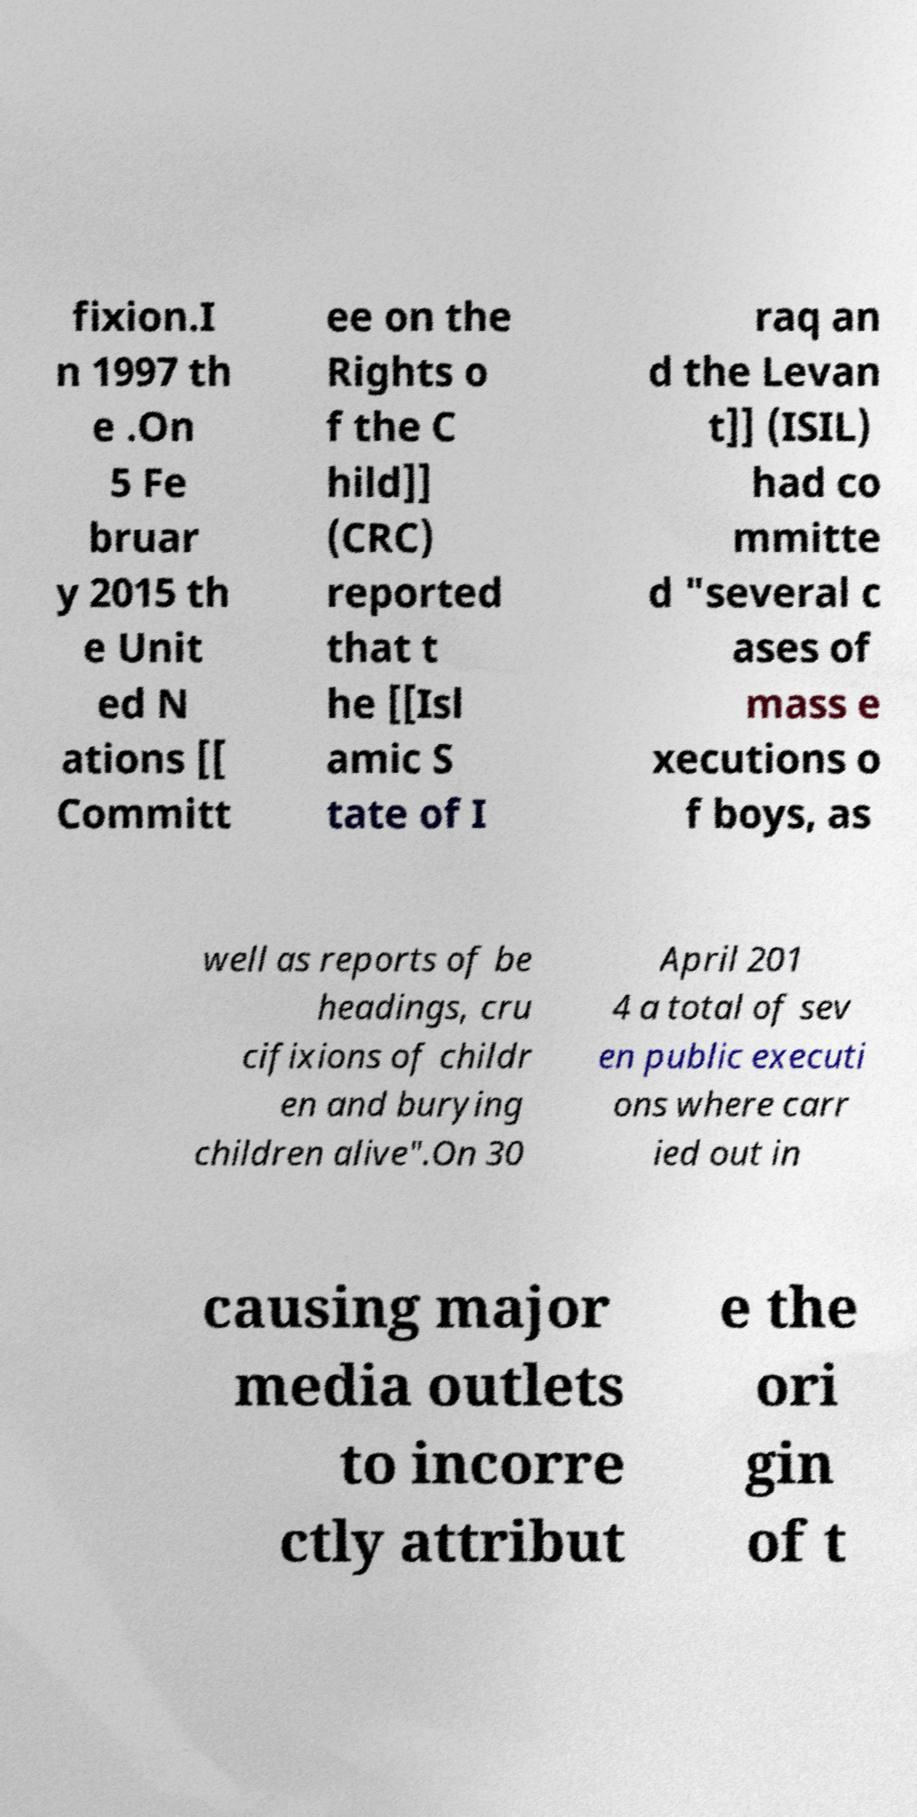For documentation purposes, I need the text within this image transcribed. Could you provide that? fixion.I n 1997 th e .On 5 Fe bruar y 2015 th e Unit ed N ations [[ Committ ee on the Rights o f the C hild]] (CRC) reported that t he [[Isl amic S tate of I raq an d the Levan t]] (ISIL) had co mmitte d "several c ases of mass e xecutions o f boys, as well as reports of be headings, cru cifixions of childr en and burying children alive".On 30 April 201 4 a total of sev en public executi ons where carr ied out in causing major media outlets to incorre ctly attribut e the ori gin of t 